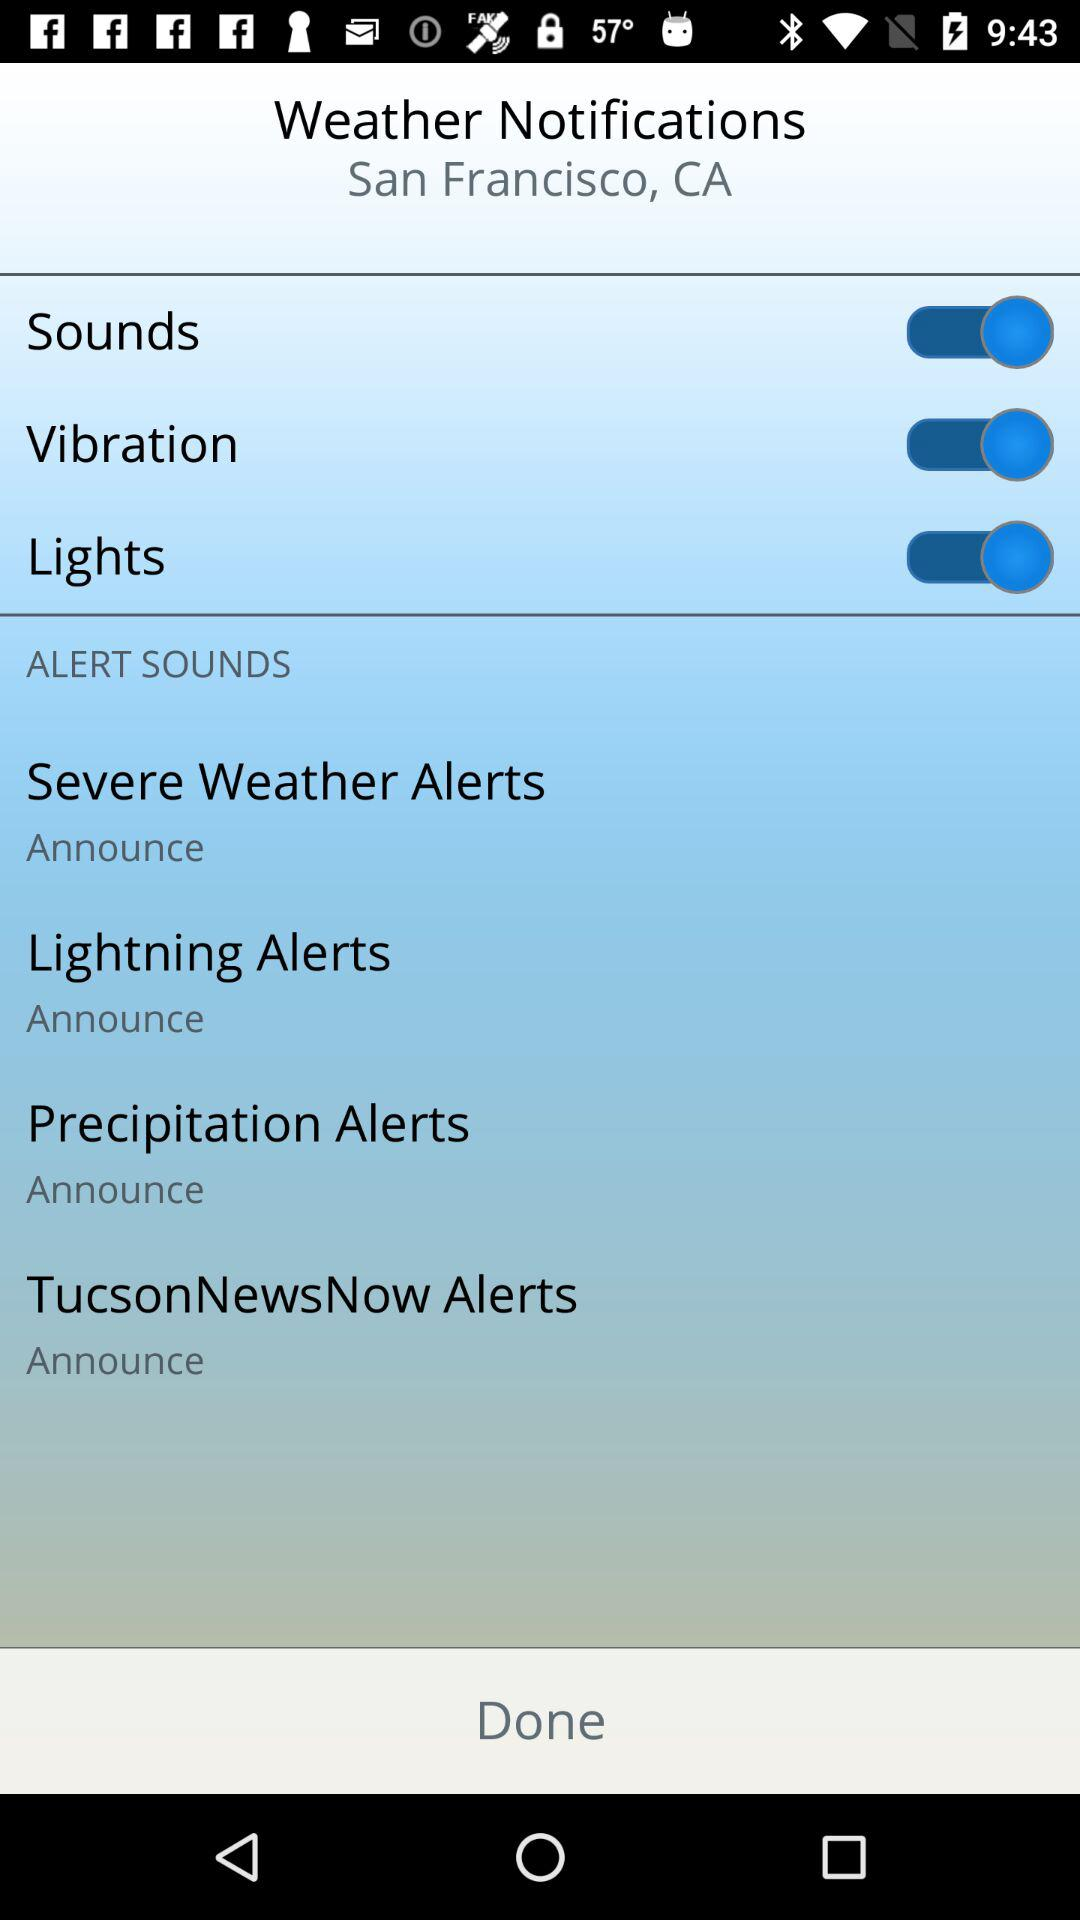What is the status of the "Lights" notification setting? The status of the "Lights" notification setting is "on". 